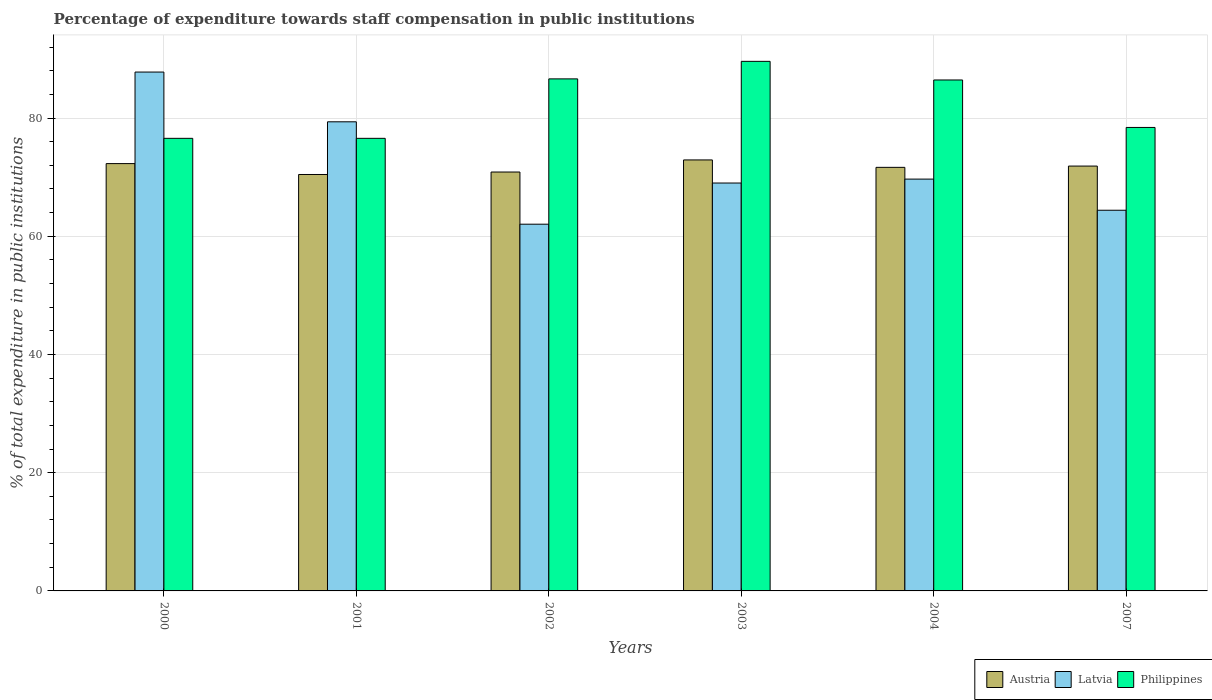In how many cases, is the number of bars for a given year not equal to the number of legend labels?
Offer a very short reply. 0. What is the percentage of expenditure towards staff compensation in Austria in 2004?
Make the answer very short. 71.66. Across all years, what is the maximum percentage of expenditure towards staff compensation in Latvia?
Offer a terse response. 87.78. Across all years, what is the minimum percentage of expenditure towards staff compensation in Philippines?
Keep it short and to the point. 76.57. In which year was the percentage of expenditure towards staff compensation in Latvia minimum?
Ensure brevity in your answer.  2002. What is the total percentage of expenditure towards staff compensation in Austria in the graph?
Offer a very short reply. 430.07. What is the difference between the percentage of expenditure towards staff compensation in Philippines in 2003 and that in 2004?
Make the answer very short. 3.15. What is the difference between the percentage of expenditure towards staff compensation in Latvia in 2002 and the percentage of expenditure towards staff compensation in Philippines in 2004?
Give a very brief answer. -24.4. What is the average percentage of expenditure towards staff compensation in Latvia per year?
Your answer should be very brief. 72.05. In the year 2003, what is the difference between the percentage of expenditure towards staff compensation in Philippines and percentage of expenditure towards staff compensation in Austria?
Keep it short and to the point. 16.68. In how many years, is the percentage of expenditure towards staff compensation in Philippines greater than 76 %?
Provide a succinct answer. 6. What is the ratio of the percentage of expenditure towards staff compensation in Latvia in 2000 to that in 2004?
Your answer should be very brief. 1.26. What is the difference between the highest and the second highest percentage of expenditure towards staff compensation in Austria?
Your answer should be very brief. 0.62. What is the difference between the highest and the lowest percentage of expenditure towards staff compensation in Philippines?
Provide a succinct answer. 13.02. What does the 1st bar from the right in 2004 represents?
Make the answer very short. Philippines. How many bars are there?
Your answer should be very brief. 18. How many years are there in the graph?
Your answer should be compact. 6. Does the graph contain any zero values?
Your answer should be very brief. No. Does the graph contain grids?
Keep it short and to the point. Yes. Where does the legend appear in the graph?
Give a very brief answer. Bottom right. What is the title of the graph?
Ensure brevity in your answer.  Percentage of expenditure towards staff compensation in public institutions. Does "Libya" appear as one of the legend labels in the graph?
Your answer should be very brief. No. What is the label or title of the Y-axis?
Provide a succinct answer. % of total expenditure in public institutions. What is the % of total expenditure in public institutions of Austria in 2000?
Your response must be concise. 72.29. What is the % of total expenditure in public institutions of Latvia in 2000?
Provide a short and direct response. 87.78. What is the % of total expenditure in public institutions in Philippines in 2000?
Keep it short and to the point. 76.57. What is the % of total expenditure in public institutions in Austria in 2001?
Offer a very short reply. 70.45. What is the % of total expenditure in public institutions in Latvia in 2001?
Your response must be concise. 79.37. What is the % of total expenditure in public institutions in Philippines in 2001?
Give a very brief answer. 76.57. What is the % of total expenditure in public institutions of Austria in 2002?
Your answer should be very brief. 70.87. What is the % of total expenditure in public institutions in Latvia in 2002?
Give a very brief answer. 62.04. What is the % of total expenditure in public institutions in Philippines in 2002?
Provide a succinct answer. 86.63. What is the % of total expenditure in public institutions in Austria in 2003?
Give a very brief answer. 72.92. What is the % of total expenditure in public institutions in Latvia in 2003?
Keep it short and to the point. 69.01. What is the % of total expenditure in public institutions in Philippines in 2003?
Provide a short and direct response. 89.59. What is the % of total expenditure in public institutions of Austria in 2004?
Keep it short and to the point. 71.66. What is the % of total expenditure in public institutions of Latvia in 2004?
Ensure brevity in your answer.  69.67. What is the % of total expenditure in public institutions in Philippines in 2004?
Keep it short and to the point. 86.44. What is the % of total expenditure in public institutions in Austria in 2007?
Ensure brevity in your answer.  71.88. What is the % of total expenditure in public institutions of Latvia in 2007?
Ensure brevity in your answer.  64.4. What is the % of total expenditure in public institutions of Philippines in 2007?
Offer a very short reply. 78.41. Across all years, what is the maximum % of total expenditure in public institutions in Austria?
Your response must be concise. 72.92. Across all years, what is the maximum % of total expenditure in public institutions in Latvia?
Keep it short and to the point. 87.78. Across all years, what is the maximum % of total expenditure in public institutions in Philippines?
Your answer should be very brief. 89.59. Across all years, what is the minimum % of total expenditure in public institutions in Austria?
Make the answer very short. 70.45. Across all years, what is the minimum % of total expenditure in public institutions of Latvia?
Offer a terse response. 62.04. Across all years, what is the minimum % of total expenditure in public institutions in Philippines?
Your response must be concise. 76.57. What is the total % of total expenditure in public institutions in Austria in the graph?
Provide a succinct answer. 430.07. What is the total % of total expenditure in public institutions of Latvia in the graph?
Keep it short and to the point. 432.28. What is the total % of total expenditure in public institutions of Philippines in the graph?
Give a very brief answer. 494.21. What is the difference between the % of total expenditure in public institutions in Austria in 2000 and that in 2001?
Provide a short and direct response. 1.84. What is the difference between the % of total expenditure in public institutions of Latvia in 2000 and that in 2001?
Offer a terse response. 8.42. What is the difference between the % of total expenditure in public institutions in Philippines in 2000 and that in 2001?
Make the answer very short. 0. What is the difference between the % of total expenditure in public institutions in Austria in 2000 and that in 2002?
Your answer should be very brief. 1.42. What is the difference between the % of total expenditure in public institutions in Latvia in 2000 and that in 2002?
Your answer should be compact. 25.74. What is the difference between the % of total expenditure in public institutions in Philippines in 2000 and that in 2002?
Offer a terse response. -10.06. What is the difference between the % of total expenditure in public institutions in Austria in 2000 and that in 2003?
Give a very brief answer. -0.62. What is the difference between the % of total expenditure in public institutions of Latvia in 2000 and that in 2003?
Provide a short and direct response. 18.77. What is the difference between the % of total expenditure in public institutions in Philippines in 2000 and that in 2003?
Ensure brevity in your answer.  -13.02. What is the difference between the % of total expenditure in public institutions in Austria in 2000 and that in 2004?
Your answer should be compact. 0.63. What is the difference between the % of total expenditure in public institutions of Latvia in 2000 and that in 2004?
Keep it short and to the point. 18.11. What is the difference between the % of total expenditure in public institutions of Philippines in 2000 and that in 2004?
Make the answer very short. -9.87. What is the difference between the % of total expenditure in public institutions in Austria in 2000 and that in 2007?
Your answer should be compact. 0.42. What is the difference between the % of total expenditure in public institutions of Latvia in 2000 and that in 2007?
Give a very brief answer. 23.38. What is the difference between the % of total expenditure in public institutions in Philippines in 2000 and that in 2007?
Offer a very short reply. -1.84. What is the difference between the % of total expenditure in public institutions of Austria in 2001 and that in 2002?
Offer a very short reply. -0.42. What is the difference between the % of total expenditure in public institutions in Latvia in 2001 and that in 2002?
Provide a short and direct response. 17.32. What is the difference between the % of total expenditure in public institutions in Philippines in 2001 and that in 2002?
Ensure brevity in your answer.  -10.06. What is the difference between the % of total expenditure in public institutions in Austria in 2001 and that in 2003?
Give a very brief answer. -2.46. What is the difference between the % of total expenditure in public institutions in Latvia in 2001 and that in 2003?
Your response must be concise. 10.36. What is the difference between the % of total expenditure in public institutions in Philippines in 2001 and that in 2003?
Your answer should be compact. -13.02. What is the difference between the % of total expenditure in public institutions of Austria in 2001 and that in 2004?
Offer a terse response. -1.21. What is the difference between the % of total expenditure in public institutions in Latvia in 2001 and that in 2004?
Offer a terse response. 9.69. What is the difference between the % of total expenditure in public institutions of Philippines in 2001 and that in 2004?
Keep it short and to the point. -9.87. What is the difference between the % of total expenditure in public institutions of Austria in 2001 and that in 2007?
Keep it short and to the point. -1.43. What is the difference between the % of total expenditure in public institutions of Latvia in 2001 and that in 2007?
Ensure brevity in your answer.  14.96. What is the difference between the % of total expenditure in public institutions of Philippines in 2001 and that in 2007?
Provide a short and direct response. -1.84. What is the difference between the % of total expenditure in public institutions in Austria in 2002 and that in 2003?
Offer a very short reply. -2.05. What is the difference between the % of total expenditure in public institutions in Latvia in 2002 and that in 2003?
Make the answer very short. -6.97. What is the difference between the % of total expenditure in public institutions of Philippines in 2002 and that in 2003?
Give a very brief answer. -2.96. What is the difference between the % of total expenditure in public institutions in Austria in 2002 and that in 2004?
Provide a short and direct response. -0.79. What is the difference between the % of total expenditure in public institutions of Latvia in 2002 and that in 2004?
Give a very brief answer. -7.63. What is the difference between the % of total expenditure in public institutions of Philippines in 2002 and that in 2004?
Ensure brevity in your answer.  0.19. What is the difference between the % of total expenditure in public institutions in Austria in 2002 and that in 2007?
Make the answer very short. -1.01. What is the difference between the % of total expenditure in public institutions in Latvia in 2002 and that in 2007?
Your answer should be compact. -2.36. What is the difference between the % of total expenditure in public institutions in Philippines in 2002 and that in 2007?
Your response must be concise. 8.22. What is the difference between the % of total expenditure in public institutions of Austria in 2003 and that in 2004?
Offer a very short reply. 1.25. What is the difference between the % of total expenditure in public institutions of Latvia in 2003 and that in 2004?
Give a very brief answer. -0.66. What is the difference between the % of total expenditure in public institutions of Philippines in 2003 and that in 2004?
Your answer should be compact. 3.15. What is the difference between the % of total expenditure in public institutions in Austria in 2003 and that in 2007?
Make the answer very short. 1.04. What is the difference between the % of total expenditure in public institutions of Latvia in 2003 and that in 2007?
Your answer should be compact. 4.61. What is the difference between the % of total expenditure in public institutions of Philippines in 2003 and that in 2007?
Make the answer very short. 11.18. What is the difference between the % of total expenditure in public institutions of Austria in 2004 and that in 2007?
Give a very brief answer. -0.22. What is the difference between the % of total expenditure in public institutions of Latvia in 2004 and that in 2007?
Make the answer very short. 5.27. What is the difference between the % of total expenditure in public institutions of Philippines in 2004 and that in 2007?
Your answer should be very brief. 8.03. What is the difference between the % of total expenditure in public institutions in Austria in 2000 and the % of total expenditure in public institutions in Latvia in 2001?
Make the answer very short. -7.07. What is the difference between the % of total expenditure in public institutions of Austria in 2000 and the % of total expenditure in public institutions of Philippines in 2001?
Provide a succinct answer. -4.28. What is the difference between the % of total expenditure in public institutions of Latvia in 2000 and the % of total expenditure in public institutions of Philippines in 2001?
Offer a terse response. 11.21. What is the difference between the % of total expenditure in public institutions in Austria in 2000 and the % of total expenditure in public institutions in Latvia in 2002?
Provide a succinct answer. 10.25. What is the difference between the % of total expenditure in public institutions in Austria in 2000 and the % of total expenditure in public institutions in Philippines in 2002?
Provide a succinct answer. -14.33. What is the difference between the % of total expenditure in public institutions in Latvia in 2000 and the % of total expenditure in public institutions in Philippines in 2002?
Offer a terse response. 1.16. What is the difference between the % of total expenditure in public institutions of Austria in 2000 and the % of total expenditure in public institutions of Latvia in 2003?
Provide a succinct answer. 3.28. What is the difference between the % of total expenditure in public institutions in Austria in 2000 and the % of total expenditure in public institutions in Philippines in 2003?
Offer a terse response. -17.3. What is the difference between the % of total expenditure in public institutions of Latvia in 2000 and the % of total expenditure in public institutions of Philippines in 2003?
Provide a short and direct response. -1.81. What is the difference between the % of total expenditure in public institutions of Austria in 2000 and the % of total expenditure in public institutions of Latvia in 2004?
Ensure brevity in your answer.  2.62. What is the difference between the % of total expenditure in public institutions of Austria in 2000 and the % of total expenditure in public institutions of Philippines in 2004?
Your answer should be compact. -14.15. What is the difference between the % of total expenditure in public institutions in Latvia in 2000 and the % of total expenditure in public institutions in Philippines in 2004?
Offer a very short reply. 1.34. What is the difference between the % of total expenditure in public institutions in Austria in 2000 and the % of total expenditure in public institutions in Latvia in 2007?
Offer a terse response. 7.89. What is the difference between the % of total expenditure in public institutions of Austria in 2000 and the % of total expenditure in public institutions of Philippines in 2007?
Offer a terse response. -6.12. What is the difference between the % of total expenditure in public institutions in Latvia in 2000 and the % of total expenditure in public institutions in Philippines in 2007?
Offer a very short reply. 9.37. What is the difference between the % of total expenditure in public institutions in Austria in 2001 and the % of total expenditure in public institutions in Latvia in 2002?
Provide a short and direct response. 8.41. What is the difference between the % of total expenditure in public institutions in Austria in 2001 and the % of total expenditure in public institutions in Philippines in 2002?
Ensure brevity in your answer.  -16.18. What is the difference between the % of total expenditure in public institutions in Latvia in 2001 and the % of total expenditure in public institutions in Philippines in 2002?
Ensure brevity in your answer.  -7.26. What is the difference between the % of total expenditure in public institutions in Austria in 2001 and the % of total expenditure in public institutions in Latvia in 2003?
Provide a succinct answer. 1.44. What is the difference between the % of total expenditure in public institutions in Austria in 2001 and the % of total expenditure in public institutions in Philippines in 2003?
Ensure brevity in your answer.  -19.14. What is the difference between the % of total expenditure in public institutions of Latvia in 2001 and the % of total expenditure in public institutions of Philippines in 2003?
Provide a succinct answer. -10.23. What is the difference between the % of total expenditure in public institutions of Austria in 2001 and the % of total expenditure in public institutions of Latvia in 2004?
Offer a terse response. 0.78. What is the difference between the % of total expenditure in public institutions in Austria in 2001 and the % of total expenditure in public institutions in Philippines in 2004?
Keep it short and to the point. -15.99. What is the difference between the % of total expenditure in public institutions of Latvia in 2001 and the % of total expenditure in public institutions of Philippines in 2004?
Provide a succinct answer. -7.08. What is the difference between the % of total expenditure in public institutions in Austria in 2001 and the % of total expenditure in public institutions in Latvia in 2007?
Your answer should be very brief. 6.05. What is the difference between the % of total expenditure in public institutions in Austria in 2001 and the % of total expenditure in public institutions in Philippines in 2007?
Offer a terse response. -7.96. What is the difference between the % of total expenditure in public institutions in Latvia in 2001 and the % of total expenditure in public institutions in Philippines in 2007?
Provide a succinct answer. 0.95. What is the difference between the % of total expenditure in public institutions in Austria in 2002 and the % of total expenditure in public institutions in Latvia in 2003?
Your response must be concise. 1.86. What is the difference between the % of total expenditure in public institutions of Austria in 2002 and the % of total expenditure in public institutions of Philippines in 2003?
Provide a succinct answer. -18.72. What is the difference between the % of total expenditure in public institutions in Latvia in 2002 and the % of total expenditure in public institutions in Philippines in 2003?
Keep it short and to the point. -27.55. What is the difference between the % of total expenditure in public institutions in Austria in 2002 and the % of total expenditure in public institutions in Latvia in 2004?
Your answer should be compact. 1.2. What is the difference between the % of total expenditure in public institutions of Austria in 2002 and the % of total expenditure in public institutions of Philippines in 2004?
Provide a short and direct response. -15.57. What is the difference between the % of total expenditure in public institutions in Latvia in 2002 and the % of total expenditure in public institutions in Philippines in 2004?
Offer a terse response. -24.4. What is the difference between the % of total expenditure in public institutions of Austria in 2002 and the % of total expenditure in public institutions of Latvia in 2007?
Offer a terse response. 6.47. What is the difference between the % of total expenditure in public institutions in Austria in 2002 and the % of total expenditure in public institutions in Philippines in 2007?
Your response must be concise. -7.54. What is the difference between the % of total expenditure in public institutions in Latvia in 2002 and the % of total expenditure in public institutions in Philippines in 2007?
Keep it short and to the point. -16.37. What is the difference between the % of total expenditure in public institutions of Austria in 2003 and the % of total expenditure in public institutions of Latvia in 2004?
Keep it short and to the point. 3.24. What is the difference between the % of total expenditure in public institutions of Austria in 2003 and the % of total expenditure in public institutions of Philippines in 2004?
Offer a very short reply. -13.53. What is the difference between the % of total expenditure in public institutions in Latvia in 2003 and the % of total expenditure in public institutions in Philippines in 2004?
Your response must be concise. -17.43. What is the difference between the % of total expenditure in public institutions of Austria in 2003 and the % of total expenditure in public institutions of Latvia in 2007?
Provide a succinct answer. 8.51. What is the difference between the % of total expenditure in public institutions in Austria in 2003 and the % of total expenditure in public institutions in Philippines in 2007?
Offer a terse response. -5.49. What is the difference between the % of total expenditure in public institutions in Latvia in 2003 and the % of total expenditure in public institutions in Philippines in 2007?
Keep it short and to the point. -9.4. What is the difference between the % of total expenditure in public institutions of Austria in 2004 and the % of total expenditure in public institutions of Latvia in 2007?
Provide a short and direct response. 7.26. What is the difference between the % of total expenditure in public institutions of Austria in 2004 and the % of total expenditure in public institutions of Philippines in 2007?
Your response must be concise. -6.75. What is the difference between the % of total expenditure in public institutions of Latvia in 2004 and the % of total expenditure in public institutions of Philippines in 2007?
Offer a very short reply. -8.74. What is the average % of total expenditure in public institutions in Austria per year?
Give a very brief answer. 71.68. What is the average % of total expenditure in public institutions in Latvia per year?
Your answer should be compact. 72.05. What is the average % of total expenditure in public institutions of Philippines per year?
Your answer should be very brief. 82.37. In the year 2000, what is the difference between the % of total expenditure in public institutions in Austria and % of total expenditure in public institutions in Latvia?
Keep it short and to the point. -15.49. In the year 2000, what is the difference between the % of total expenditure in public institutions in Austria and % of total expenditure in public institutions in Philippines?
Provide a short and direct response. -4.28. In the year 2000, what is the difference between the % of total expenditure in public institutions in Latvia and % of total expenditure in public institutions in Philippines?
Provide a short and direct response. 11.21. In the year 2001, what is the difference between the % of total expenditure in public institutions of Austria and % of total expenditure in public institutions of Latvia?
Ensure brevity in your answer.  -8.91. In the year 2001, what is the difference between the % of total expenditure in public institutions in Austria and % of total expenditure in public institutions in Philippines?
Make the answer very short. -6.12. In the year 2001, what is the difference between the % of total expenditure in public institutions in Latvia and % of total expenditure in public institutions in Philippines?
Give a very brief answer. 2.8. In the year 2002, what is the difference between the % of total expenditure in public institutions of Austria and % of total expenditure in public institutions of Latvia?
Keep it short and to the point. 8.83. In the year 2002, what is the difference between the % of total expenditure in public institutions of Austria and % of total expenditure in public institutions of Philippines?
Provide a short and direct response. -15.76. In the year 2002, what is the difference between the % of total expenditure in public institutions in Latvia and % of total expenditure in public institutions in Philippines?
Your response must be concise. -24.58. In the year 2003, what is the difference between the % of total expenditure in public institutions in Austria and % of total expenditure in public institutions in Latvia?
Your response must be concise. 3.91. In the year 2003, what is the difference between the % of total expenditure in public institutions of Austria and % of total expenditure in public institutions of Philippines?
Ensure brevity in your answer.  -16.68. In the year 2003, what is the difference between the % of total expenditure in public institutions of Latvia and % of total expenditure in public institutions of Philippines?
Make the answer very short. -20.58. In the year 2004, what is the difference between the % of total expenditure in public institutions in Austria and % of total expenditure in public institutions in Latvia?
Your answer should be compact. 1.99. In the year 2004, what is the difference between the % of total expenditure in public institutions in Austria and % of total expenditure in public institutions in Philippines?
Your answer should be compact. -14.78. In the year 2004, what is the difference between the % of total expenditure in public institutions of Latvia and % of total expenditure in public institutions of Philippines?
Your answer should be compact. -16.77. In the year 2007, what is the difference between the % of total expenditure in public institutions in Austria and % of total expenditure in public institutions in Latvia?
Ensure brevity in your answer.  7.47. In the year 2007, what is the difference between the % of total expenditure in public institutions in Austria and % of total expenditure in public institutions in Philippines?
Offer a terse response. -6.53. In the year 2007, what is the difference between the % of total expenditure in public institutions in Latvia and % of total expenditure in public institutions in Philippines?
Make the answer very short. -14.01. What is the ratio of the % of total expenditure in public institutions in Austria in 2000 to that in 2001?
Your answer should be very brief. 1.03. What is the ratio of the % of total expenditure in public institutions in Latvia in 2000 to that in 2001?
Offer a terse response. 1.11. What is the ratio of the % of total expenditure in public institutions in Philippines in 2000 to that in 2001?
Provide a succinct answer. 1. What is the ratio of the % of total expenditure in public institutions in Austria in 2000 to that in 2002?
Your response must be concise. 1.02. What is the ratio of the % of total expenditure in public institutions of Latvia in 2000 to that in 2002?
Your answer should be very brief. 1.41. What is the ratio of the % of total expenditure in public institutions in Philippines in 2000 to that in 2002?
Offer a very short reply. 0.88. What is the ratio of the % of total expenditure in public institutions in Latvia in 2000 to that in 2003?
Your response must be concise. 1.27. What is the ratio of the % of total expenditure in public institutions of Philippines in 2000 to that in 2003?
Make the answer very short. 0.85. What is the ratio of the % of total expenditure in public institutions in Austria in 2000 to that in 2004?
Give a very brief answer. 1.01. What is the ratio of the % of total expenditure in public institutions of Latvia in 2000 to that in 2004?
Offer a very short reply. 1.26. What is the ratio of the % of total expenditure in public institutions of Philippines in 2000 to that in 2004?
Your response must be concise. 0.89. What is the ratio of the % of total expenditure in public institutions in Latvia in 2000 to that in 2007?
Keep it short and to the point. 1.36. What is the ratio of the % of total expenditure in public institutions of Philippines in 2000 to that in 2007?
Keep it short and to the point. 0.98. What is the ratio of the % of total expenditure in public institutions in Latvia in 2001 to that in 2002?
Keep it short and to the point. 1.28. What is the ratio of the % of total expenditure in public institutions in Philippines in 2001 to that in 2002?
Your answer should be compact. 0.88. What is the ratio of the % of total expenditure in public institutions of Austria in 2001 to that in 2003?
Make the answer very short. 0.97. What is the ratio of the % of total expenditure in public institutions in Latvia in 2001 to that in 2003?
Offer a very short reply. 1.15. What is the ratio of the % of total expenditure in public institutions in Philippines in 2001 to that in 2003?
Offer a very short reply. 0.85. What is the ratio of the % of total expenditure in public institutions in Austria in 2001 to that in 2004?
Your response must be concise. 0.98. What is the ratio of the % of total expenditure in public institutions in Latvia in 2001 to that in 2004?
Offer a very short reply. 1.14. What is the ratio of the % of total expenditure in public institutions in Philippines in 2001 to that in 2004?
Keep it short and to the point. 0.89. What is the ratio of the % of total expenditure in public institutions in Austria in 2001 to that in 2007?
Offer a very short reply. 0.98. What is the ratio of the % of total expenditure in public institutions in Latvia in 2001 to that in 2007?
Provide a succinct answer. 1.23. What is the ratio of the % of total expenditure in public institutions in Philippines in 2001 to that in 2007?
Your response must be concise. 0.98. What is the ratio of the % of total expenditure in public institutions of Austria in 2002 to that in 2003?
Give a very brief answer. 0.97. What is the ratio of the % of total expenditure in public institutions of Latvia in 2002 to that in 2003?
Ensure brevity in your answer.  0.9. What is the ratio of the % of total expenditure in public institutions of Philippines in 2002 to that in 2003?
Ensure brevity in your answer.  0.97. What is the ratio of the % of total expenditure in public institutions in Latvia in 2002 to that in 2004?
Provide a short and direct response. 0.89. What is the ratio of the % of total expenditure in public institutions of Philippines in 2002 to that in 2004?
Provide a short and direct response. 1. What is the ratio of the % of total expenditure in public institutions in Austria in 2002 to that in 2007?
Keep it short and to the point. 0.99. What is the ratio of the % of total expenditure in public institutions of Latvia in 2002 to that in 2007?
Your answer should be compact. 0.96. What is the ratio of the % of total expenditure in public institutions of Philippines in 2002 to that in 2007?
Ensure brevity in your answer.  1.1. What is the ratio of the % of total expenditure in public institutions in Austria in 2003 to that in 2004?
Make the answer very short. 1.02. What is the ratio of the % of total expenditure in public institutions in Latvia in 2003 to that in 2004?
Keep it short and to the point. 0.99. What is the ratio of the % of total expenditure in public institutions of Philippines in 2003 to that in 2004?
Ensure brevity in your answer.  1.04. What is the ratio of the % of total expenditure in public institutions in Austria in 2003 to that in 2007?
Give a very brief answer. 1.01. What is the ratio of the % of total expenditure in public institutions in Latvia in 2003 to that in 2007?
Keep it short and to the point. 1.07. What is the ratio of the % of total expenditure in public institutions of Philippines in 2003 to that in 2007?
Give a very brief answer. 1.14. What is the ratio of the % of total expenditure in public institutions in Latvia in 2004 to that in 2007?
Provide a short and direct response. 1.08. What is the ratio of the % of total expenditure in public institutions of Philippines in 2004 to that in 2007?
Offer a terse response. 1.1. What is the difference between the highest and the second highest % of total expenditure in public institutions of Austria?
Offer a terse response. 0.62. What is the difference between the highest and the second highest % of total expenditure in public institutions in Latvia?
Offer a very short reply. 8.42. What is the difference between the highest and the second highest % of total expenditure in public institutions in Philippines?
Make the answer very short. 2.96. What is the difference between the highest and the lowest % of total expenditure in public institutions in Austria?
Your answer should be compact. 2.46. What is the difference between the highest and the lowest % of total expenditure in public institutions in Latvia?
Provide a succinct answer. 25.74. What is the difference between the highest and the lowest % of total expenditure in public institutions of Philippines?
Keep it short and to the point. 13.02. 